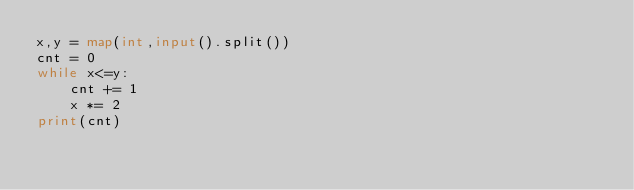Convert code to text. <code><loc_0><loc_0><loc_500><loc_500><_Python_>x,y = map(int,input().split())
cnt = 0
while x<=y:
    cnt += 1
    x *= 2
print(cnt)</code> 